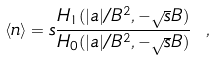<formula> <loc_0><loc_0><loc_500><loc_500>\langle n \rangle = s { \frac { H _ { 1 } ( | a | / B ^ { 2 } , - \sqrt { s } B ) } { H _ { 0 } ( | a | / B ^ { 2 } , - \sqrt { s } B ) } } \ ,</formula> 